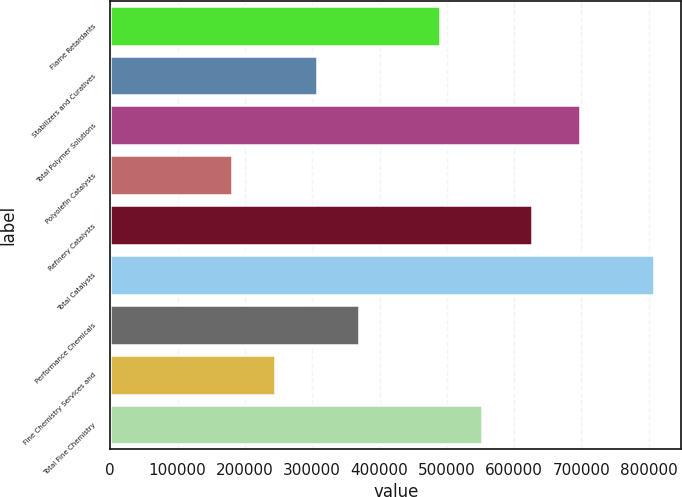Convert chart. <chart><loc_0><loc_0><loc_500><loc_500><bar_chart><fcel>Flame Retardants<fcel>Stabilizers and Curatives<fcel>Total Polymer Solutions<fcel>Polyolefin Catalysts<fcel>Refinery Catalysts<fcel>Total Catalysts<fcel>Performance Chemicals<fcel>Fine Chemistry Services and<fcel>Total Fine Chemistry<nl><fcel>489484<fcel>306737<fcel>697206<fcel>181406<fcel>626657<fcel>808063<fcel>369403<fcel>244072<fcel>552150<nl></chart> 